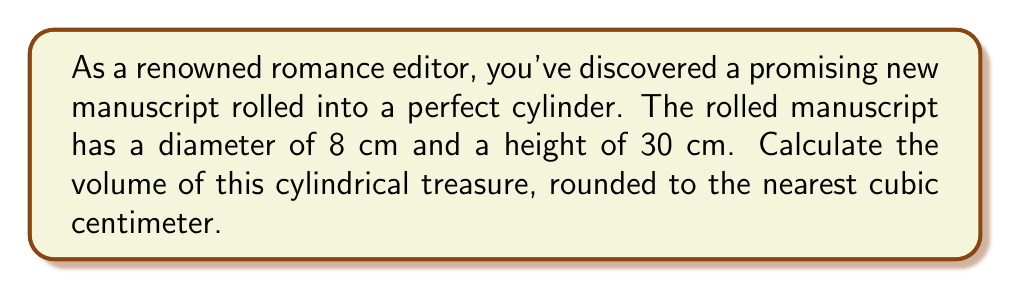Solve this math problem. To find the volume of a cylinder, we use the formula:

$$V = \pi r^2 h$$

Where:
$V$ = volume
$r$ = radius of the base
$h$ = height of the cylinder

Steps:
1. Determine the radius:
   The diameter is 8 cm, so the radius is half of that.
   $r = 8 \div 2 = 4$ cm

2. Substitute the values into the formula:
   $$V = \pi (4\text{ cm})^2 (30\text{ cm})$$

3. Calculate:
   $$V = \pi (16\text{ cm}^2) (30\text{ cm})$$
   $$V = 480\pi\text{ cm}^3$$

4. Evaluate and round to the nearest cubic centimeter:
   $$V \approx 1,507.96\text{ cm}^3 \approx 1,508\text{ cm}^3$$

[asy]
import geometry;

size(200);
real r = 4;
real h = 30;
path p = (0,0)--(0,h)--(2r,h)--(2r,0)--cycle;
revolution cyl = revolution(p,Z);
draw(cyl,lightgray);
draw(surface(cyl),lightgray+opacity(0.3));
label("30 cm",(-1,h/2),W);
label("8 cm",(r,-1),S);
draw((0,-2)--(2r,-2),Arrows(2));
[/asy]
Answer: $1,508\text{ cm}^3$ 